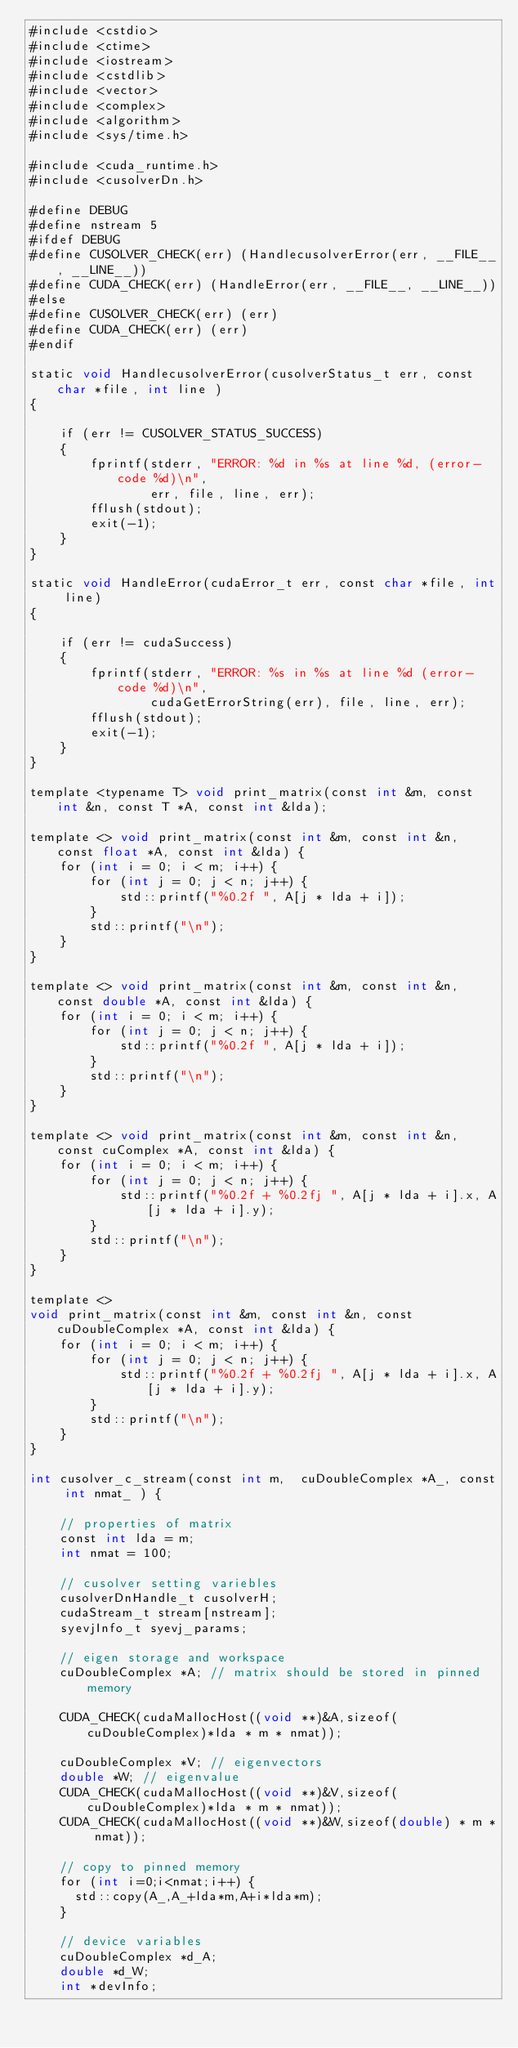<code> <loc_0><loc_0><loc_500><loc_500><_Cuda_>#include <cstdio>
#include <ctime>
#include <iostream>
#include <cstdlib>
#include <vector>
#include <complex>
#include <algorithm>
#include <sys/time.h>

#include <cuda_runtime.h>
#include <cusolverDn.h>

#define DEBUG
#define nstream 5 
#ifdef DEBUG
#define CUSOLVER_CHECK(err) (HandlecusolverError(err, __FILE__, __LINE__))
#define CUDA_CHECK(err) (HandleError(err, __FILE__, __LINE__))
#else
#define CUSOLVER_CHECK(err) (err)
#define CUDA_CHECK(err) (err)
#endif

static void HandlecusolverError(cusolverStatus_t err, const char *file, int line )
{

    if (err != CUSOLVER_STATUS_SUCCESS)
    {
        fprintf(stderr, "ERROR: %d in %s at line %d, (error-code %d)\n",
                err, file, line, err);
        fflush(stdout);
        exit(-1);
    }
}

static void HandleError(cudaError_t err, const char *file, int line)
{

    if (err != cudaSuccess)
    {
        fprintf(stderr, "ERROR: %s in %s at line %d (error-code %d)\n",
                cudaGetErrorString(err), file, line, err);
        fflush(stdout);
        exit(-1);
    }
}

template <typename T> void print_matrix(const int &m, const int &n, const T *A, const int &lda);

template <> void print_matrix(const int &m, const int &n, const float *A, const int &lda) {
    for (int i = 0; i < m; i++) {
        for (int j = 0; j < n; j++) {
            std::printf("%0.2f ", A[j * lda + i]);
        }
        std::printf("\n");
    }
}

template <> void print_matrix(const int &m, const int &n, const double *A, const int &lda) {
    for (int i = 0; i < m; i++) {
        for (int j = 0; j < n; j++) {
            std::printf("%0.2f ", A[j * lda + i]);
        }
        std::printf("\n");
    }
}

template <> void print_matrix(const int &m, const int &n, const cuComplex *A, const int &lda) {
    for (int i = 0; i < m; i++) {
        for (int j = 0; j < n; j++) {
            std::printf("%0.2f + %0.2fj ", A[j * lda + i].x, A[j * lda + i].y);
        }
        std::printf("\n");
    }
}

template <>
void print_matrix(const int &m, const int &n, const cuDoubleComplex *A, const int &lda) {
    for (int i = 0; i < m; i++) {
        for (int j = 0; j < n; j++) {
            std::printf("%0.2f + %0.2fj ", A[j * lda + i].x, A[j * lda + i].y);
        }
        std::printf("\n");
    }
}

int cusolver_c_stream(const int m,  cuDoubleComplex *A_, const int nmat_ ) {

    // properties of matrix
    const int lda = m;
    int nmat = 100;

    // cusolver setting variebles
    cusolverDnHandle_t cusolverH;
    cudaStream_t stream[nstream];
    syevjInfo_t syevj_params;

    // eigen storage and workspace
    cuDoubleComplex *A; // matrix should be stored in pinned memory

    CUDA_CHECK(cudaMallocHost((void **)&A,sizeof(cuDoubleComplex)*lda * m * nmat));

    cuDoubleComplex *V; // eigenvectors
    double *W; // eigenvalue
    CUDA_CHECK(cudaMallocHost((void **)&V,sizeof(cuDoubleComplex)*lda * m * nmat));
    CUDA_CHECK(cudaMallocHost((void **)&W,sizeof(double) * m * nmat));

    // copy to pinned memory
    for (int i=0;i<nmat;i++) {
      std::copy(A_,A_+lda*m,A+i*lda*m);
    }

    // device variables
    cuDoubleComplex *d_A;
    double *d_W;
    int *devInfo;</code> 